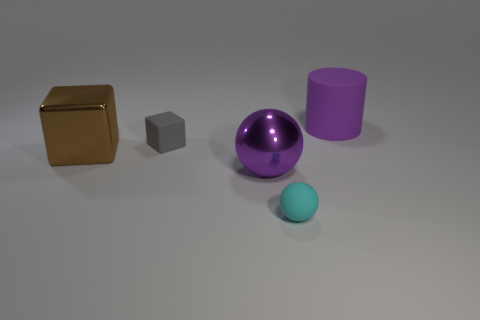What number of balls are behind the large brown metal cube?
Your response must be concise. 0. How many tiny gray blocks are the same material as the large purple cylinder?
Offer a very short reply. 1. What is the color of the ball that is the same material as the cylinder?
Provide a succinct answer. Cyan. The small thing on the left side of the ball to the left of the thing in front of the purple ball is made of what material?
Offer a terse response. Rubber. Do the purple object in front of the brown thing and the cylinder have the same size?
Keep it short and to the point. Yes. What number of tiny things are purple cubes or brown metallic objects?
Your response must be concise. 0. Are there any other big metallic cylinders that have the same color as the large cylinder?
Your answer should be very brief. No. There is a object that is the same size as the cyan rubber ball; what is its shape?
Keep it short and to the point. Cube. Does the tiny rubber thing that is in front of the small rubber block have the same color as the metallic cube?
Your response must be concise. No. What number of things are either large brown cubes that are in front of the tiny gray matte cube or cyan metal cubes?
Ensure brevity in your answer.  1. 